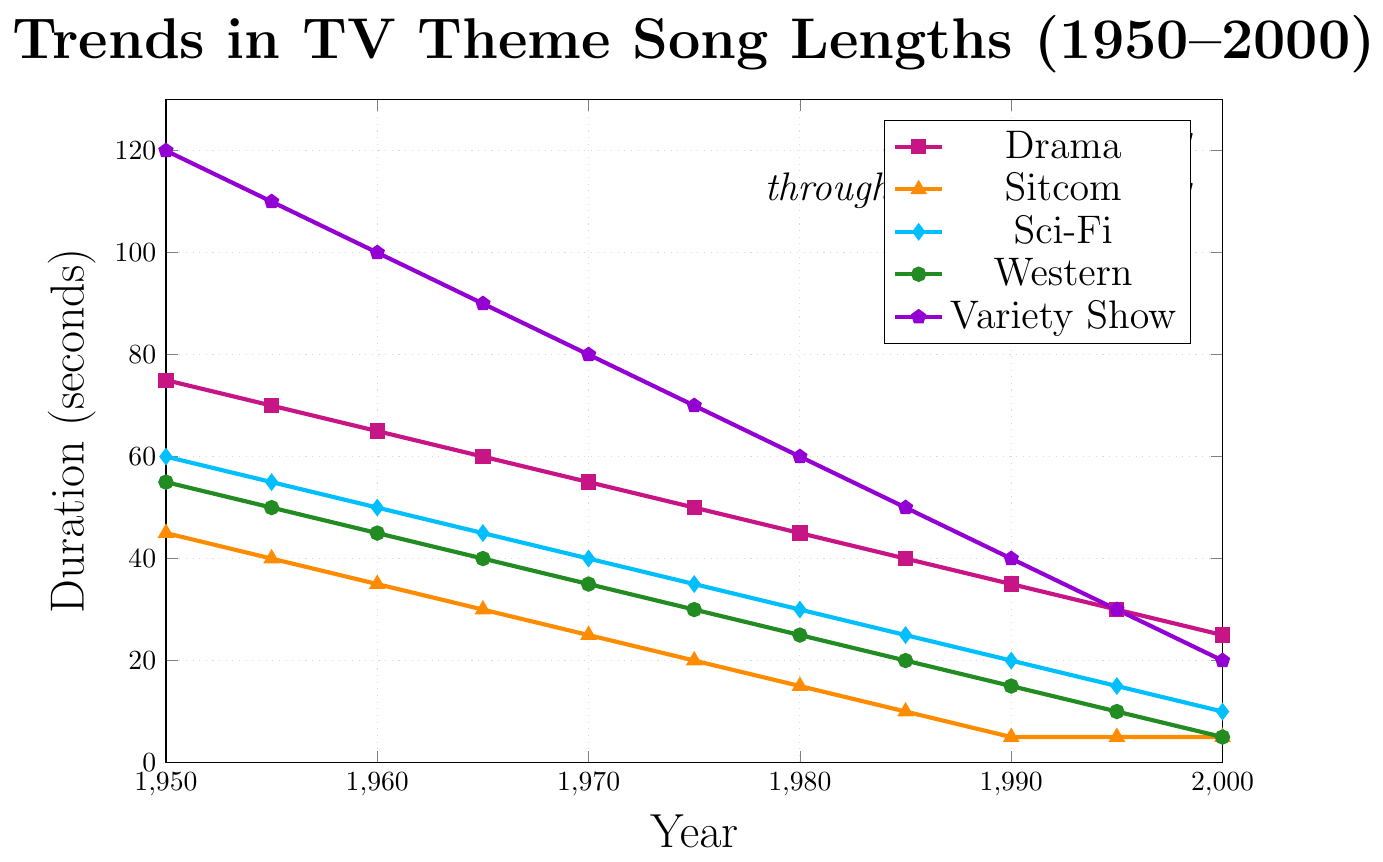What is the length of drama theme songs in the year 1975? According to the plot, in the year 1975, the length of drama theme songs falls at the intersection of the corresponding year and the drama line. This line is marked with square symbols. The value is 50 seconds.
Answer: 50 seconds Which genre had the longest theme songs in 1950? To determine which genre had the longest theme songs in 1950, observe the figure and look for the highest point on the y-axis that intersects with the year 1950. The variety show line (marked with pentagon symbols) reaches the highest value at 120 seconds.
Answer: Variety Show By how much did the theme song length for sitcoms decrease from 1950 to 2000? Locate the sitcom line marked with triangle symbols. In 1950, the length was 45 seconds, and in 2000, it was 5 seconds. The difference is 45 - 5 = 40 seconds.
Answer: 40 seconds What can you say about the trend in the theme song lengths for Sci-Fi between 1950 to 2000? The Sci-Fi line, marked with diamond symbols, consistently decreases from 60 seconds in 1950 to 10 seconds in 2000. This indicates a downward trend over the years.
Answer: Downward trend Which genre has the most rapid decrease in theme song length over the 50-year span? Compare the visual slopes of all the lines. The variety show line, marked with pentagon symbols, shows the steepest decline from 120 seconds in 1950 to 20 seconds in 2000, indicating the most rapid decrease.
Answer: Variety Show At what year do Sitcom and Western theme songs both have the same length? Observe where the sitcom line (triangle symbols) and the western line (circle symbols) intersect. They both have a duration of 5 seconds in the year 2000.
Answer: 2000 On average, how many seconds did the theme songs shorten per year for Dramas from 1950 to 2000? The length of drama theme songs was 75 seconds in 1950 and 25 seconds in 2000. The decrease over 50 years is 75 - 25 = 50 seconds. Dividing this by 50 years gives an average decrease of 1 second per year.
Answer: 1 second per year Which genre had theme songs of 30 seconds in the year 1985, and how many genres had shorter theme songs than this genre in the same year? The Sci-Fi genre had theme songs of 30 seconds in 1985. In the same year, sitcoms (10 seconds), Dramas (40 seconds), Western (20 seconds), and Variety Show (50 seconds) had shorter theme songs, indicating none were shorter.
Answer: Sci-Fi; 0 genres What is the difference between the longest and shortest theme song length across all genres in 1960? In 1960, the longest theme song was for Variety Shows at 100 seconds, and the shortest was for Sitcoms at 35 seconds. The difference is 100 - 35 = 65 seconds.
Answer: 65 seconds 